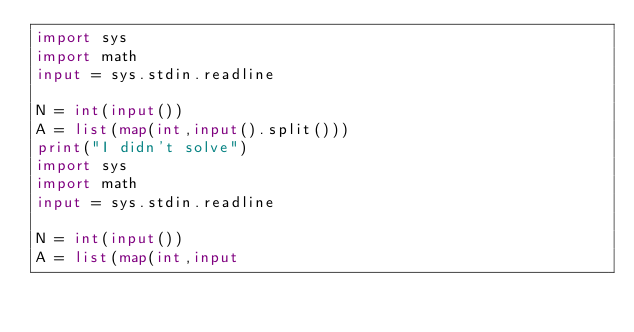<code> <loc_0><loc_0><loc_500><loc_500><_Python_>import sys
import math
input = sys.stdin.readline

N = int(input())
A = list(map(int,input().split()))
print("I didn't solve")
import sys
import math
input = sys.stdin.readline

N = int(input())
A = list(map(int,input</code> 